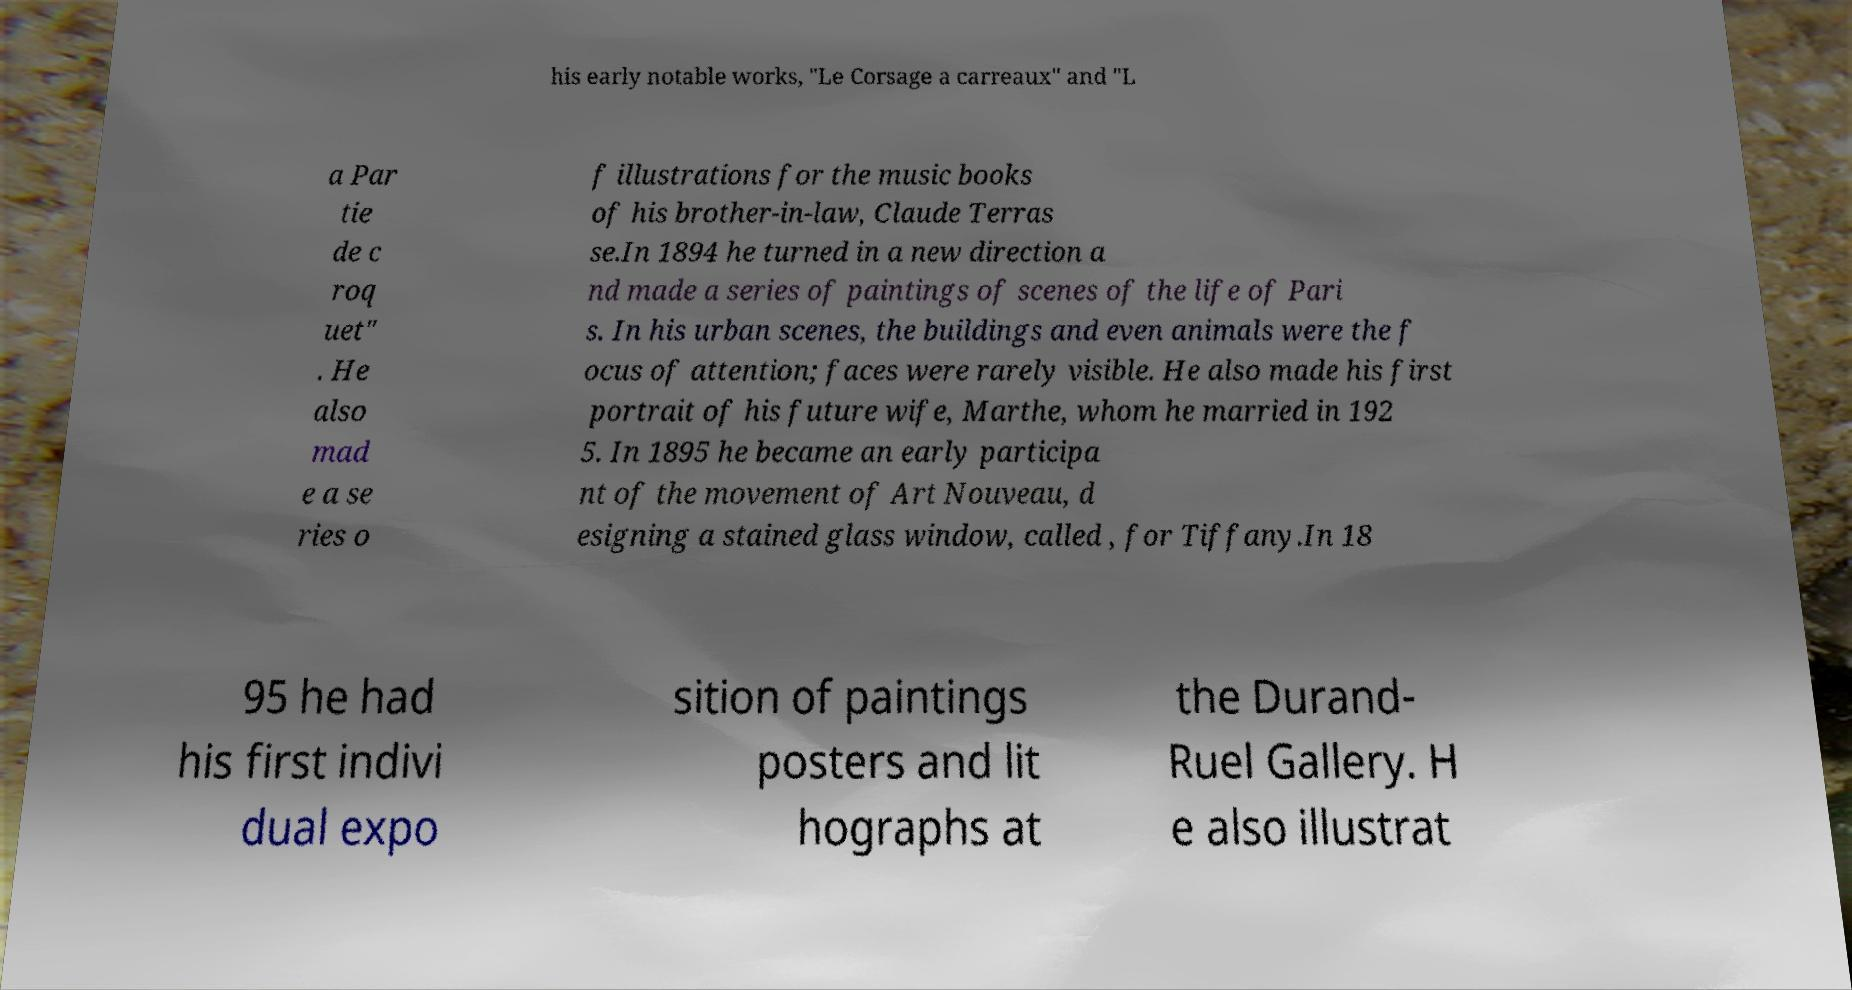I need the written content from this picture converted into text. Can you do that? his early notable works, "Le Corsage a carreaux" and "L a Par tie de c roq uet" . He also mad e a se ries o f illustrations for the music books of his brother-in-law, Claude Terras se.In 1894 he turned in a new direction a nd made a series of paintings of scenes of the life of Pari s. In his urban scenes, the buildings and even animals were the f ocus of attention; faces were rarely visible. He also made his first portrait of his future wife, Marthe, whom he married in 192 5. In 1895 he became an early participa nt of the movement of Art Nouveau, d esigning a stained glass window, called , for Tiffany.In 18 95 he had his first indivi dual expo sition of paintings posters and lit hographs at the Durand- Ruel Gallery. H e also illustrat 